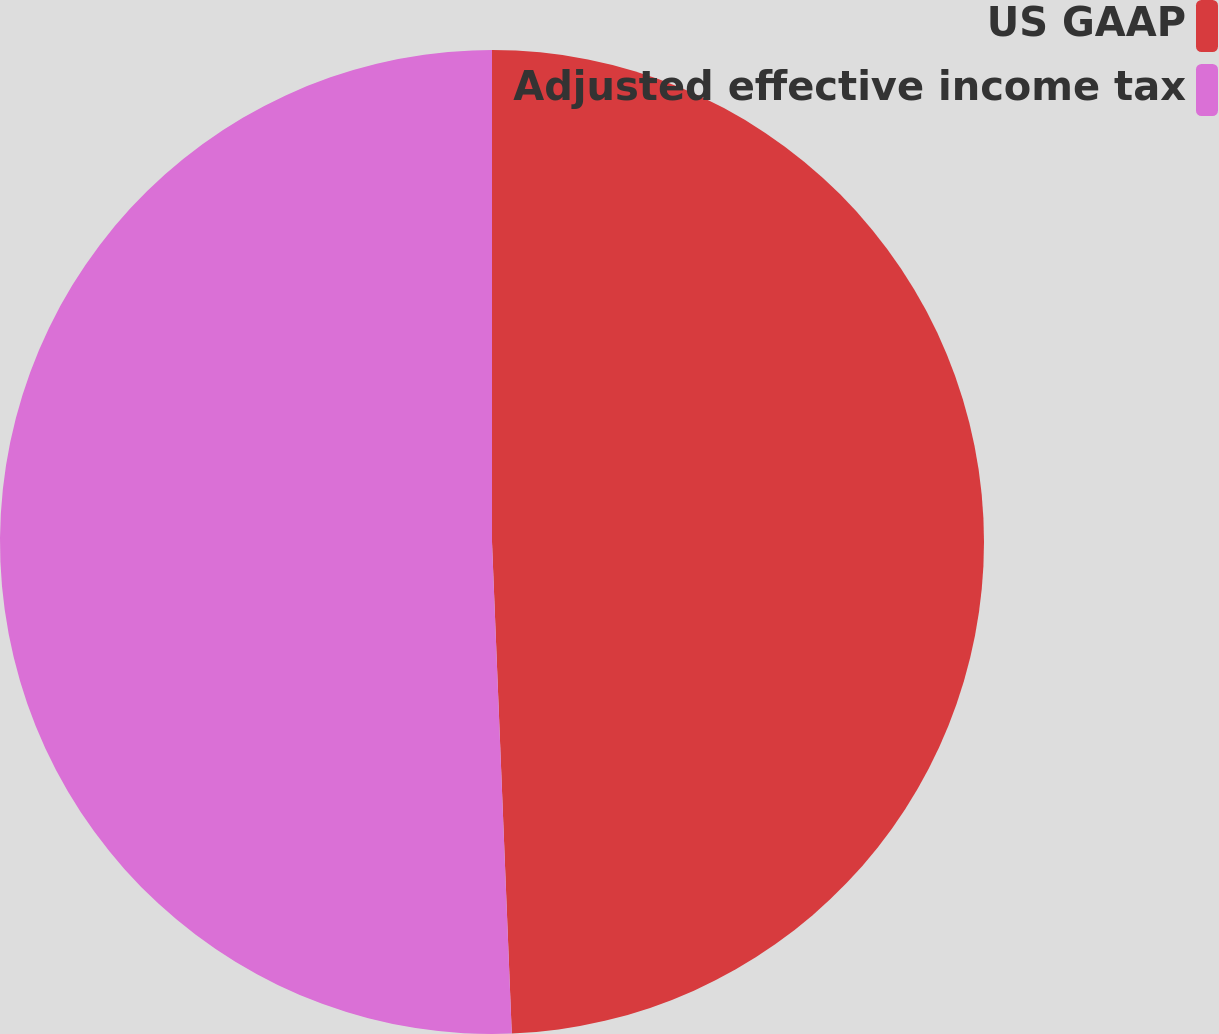Convert chart to OTSL. <chart><loc_0><loc_0><loc_500><loc_500><pie_chart><fcel>US GAAP<fcel>Adjusted effective income tax<nl><fcel>49.36%<fcel>50.64%<nl></chart> 